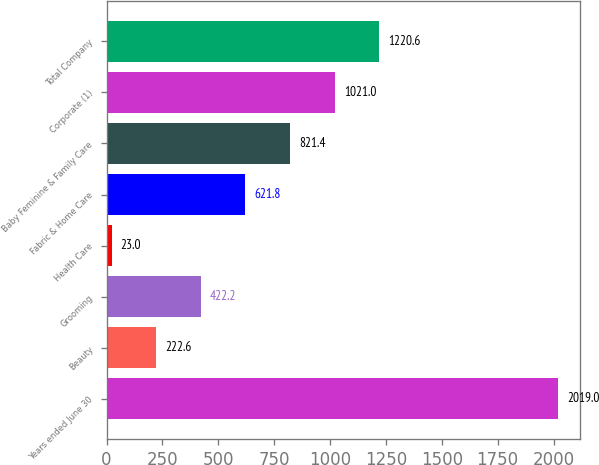Convert chart to OTSL. <chart><loc_0><loc_0><loc_500><loc_500><bar_chart><fcel>Years ended June 30<fcel>Beauty<fcel>Grooming<fcel>Health Care<fcel>Fabric & Home Care<fcel>Baby Feminine & Family Care<fcel>Corporate (1)<fcel>Total Company<nl><fcel>2019<fcel>222.6<fcel>422.2<fcel>23<fcel>621.8<fcel>821.4<fcel>1021<fcel>1220.6<nl></chart> 